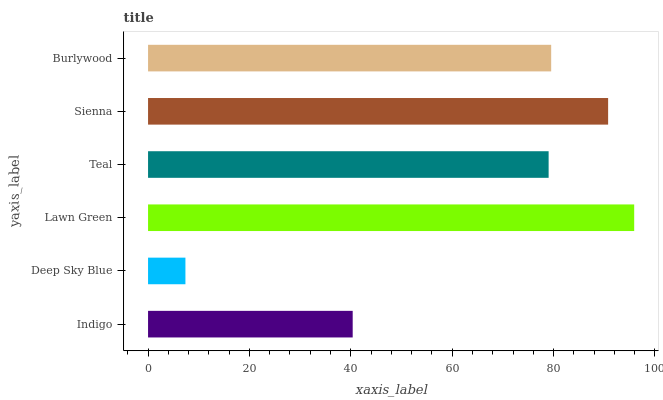Is Deep Sky Blue the minimum?
Answer yes or no. Yes. Is Lawn Green the maximum?
Answer yes or no. Yes. Is Lawn Green the minimum?
Answer yes or no. No. Is Deep Sky Blue the maximum?
Answer yes or no. No. Is Lawn Green greater than Deep Sky Blue?
Answer yes or no. Yes. Is Deep Sky Blue less than Lawn Green?
Answer yes or no. Yes. Is Deep Sky Blue greater than Lawn Green?
Answer yes or no. No. Is Lawn Green less than Deep Sky Blue?
Answer yes or no. No. Is Burlywood the high median?
Answer yes or no. Yes. Is Teal the low median?
Answer yes or no. Yes. Is Sienna the high median?
Answer yes or no. No. Is Sienna the low median?
Answer yes or no. No. 